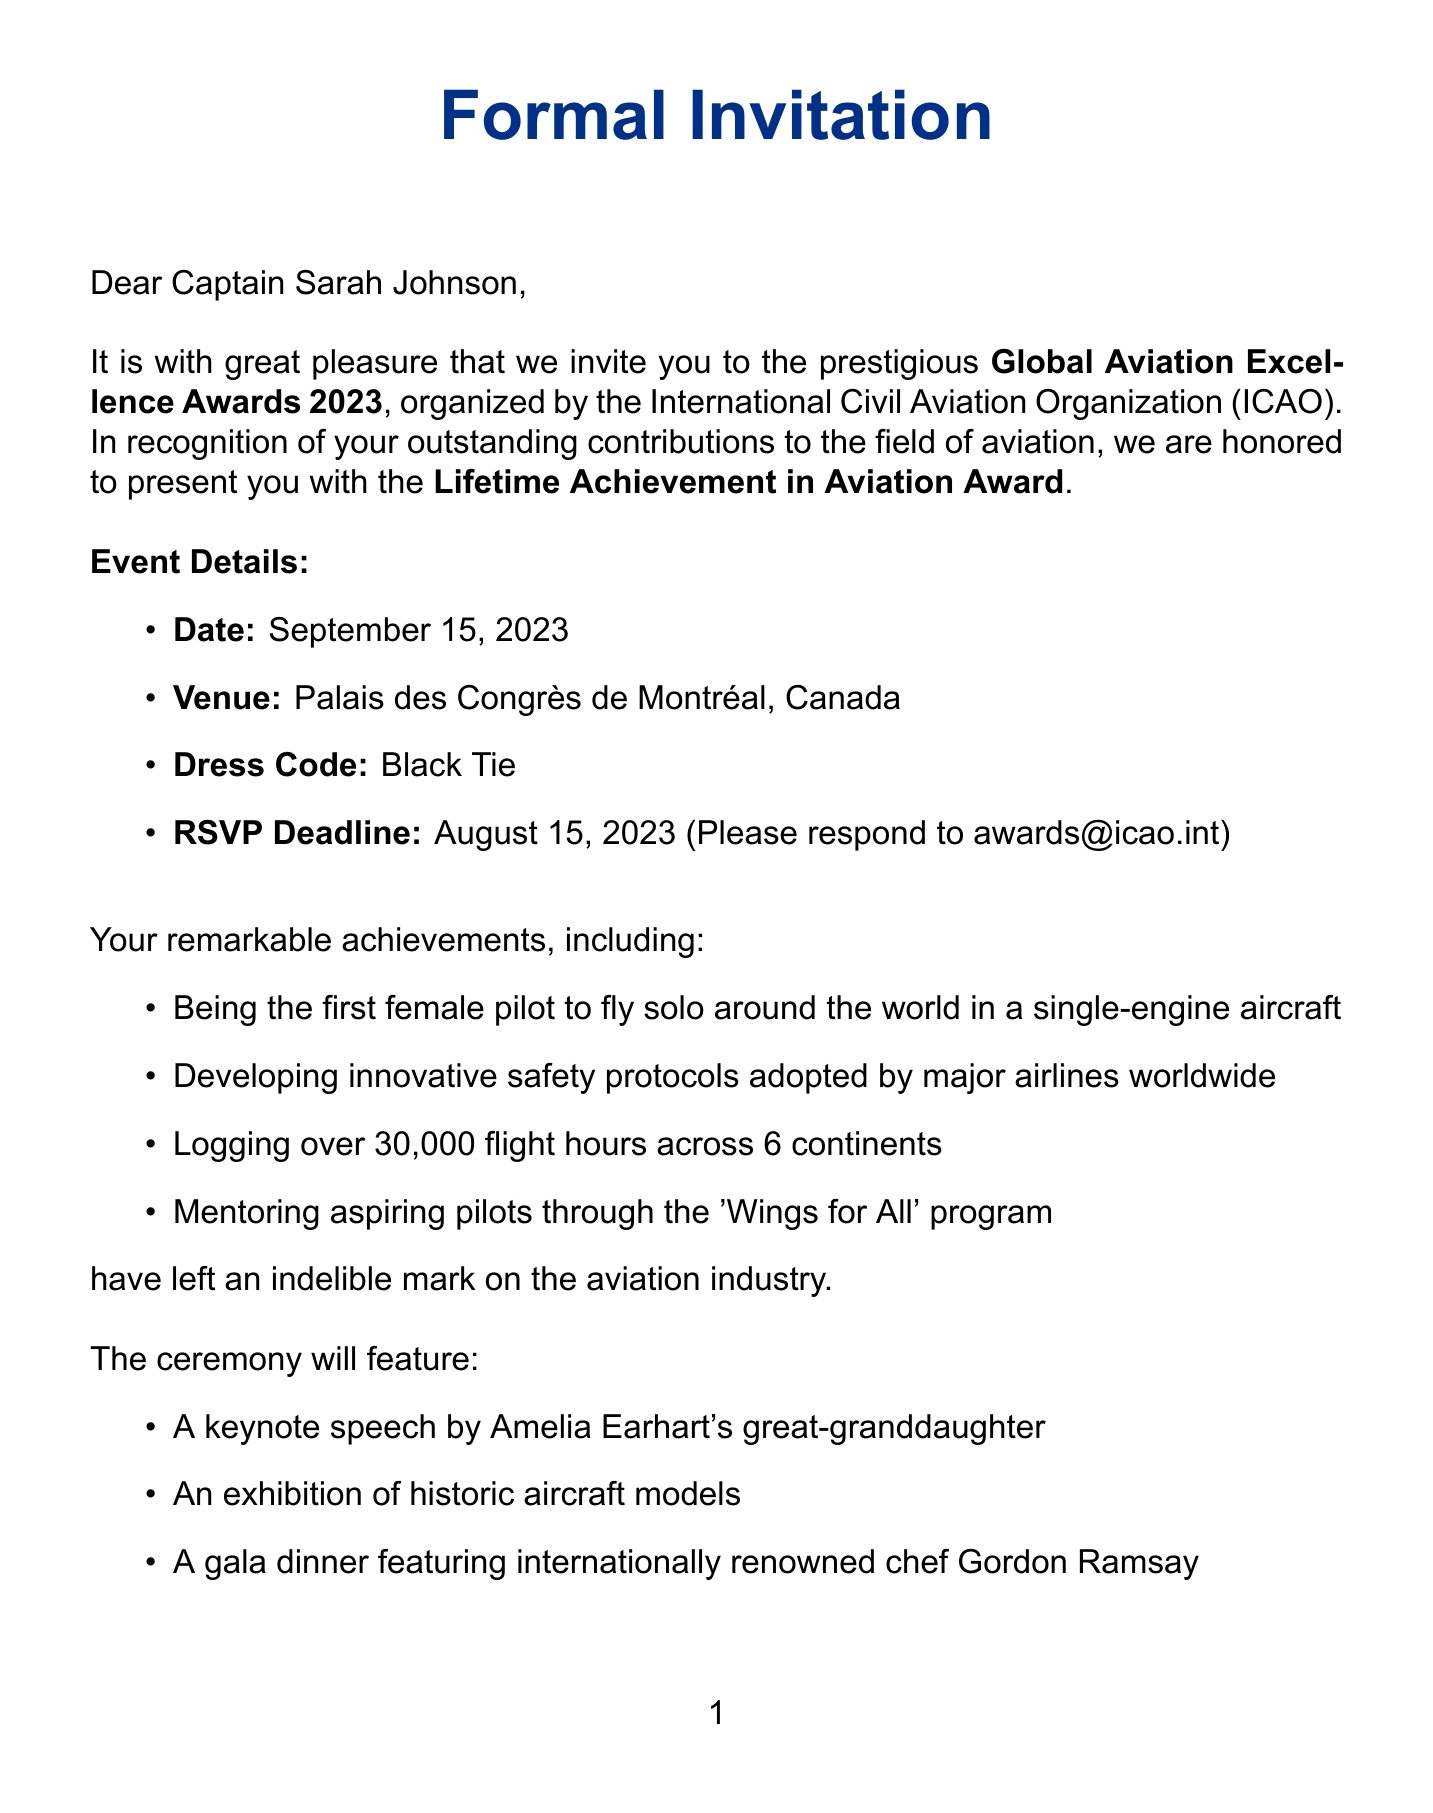What is the event name? The event name is stated in the document, which is "Global Aviation Excellence Awards 2023."
Answer: Global Aviation Excellence Awards 2023 Who is the invitation sender? The invitation sender is mentioned in the closing of the document as "Dr. Fang Liu."
Answer: Dr. Fang Liu What is the date of the ceremony? The date of the ceremony is clearly provided in the document as "September 15, 2023."
Answer: September 15, 2023 What award will Captain Sarah Johnson receive? The document specifies the award as "Lifetime Achievement in Aviation Award."
Answer: Lifetime Achievement in Aviation Award How many flight hours has Captain Sarah Johnson logged? The document indicates that Captain Sarah Johnson has logged "over 30,000 flight hours."
Answer: over 30,000 flight hours What is the dress code for the event? The dress code is explicitly stated in the document as "Black Tie."
Answer: Black Tie Who is a special guest at the ceremony? The document lists "Bertrand Piccard" as one of the special guests.
Answer: Bertrand Piccard What are the COVID-19 precautions mentioned? The document notes that "proof of vaccination required, masks optional" as the COVID-19 precautions.
Answer: proof of vaccination required, masks optional What is the accommodation arranged for the event? The accommodation mentioned in the document is "Four Seasons Hotel Montreal."
Answer: Four Seasons Hotel Montreal 